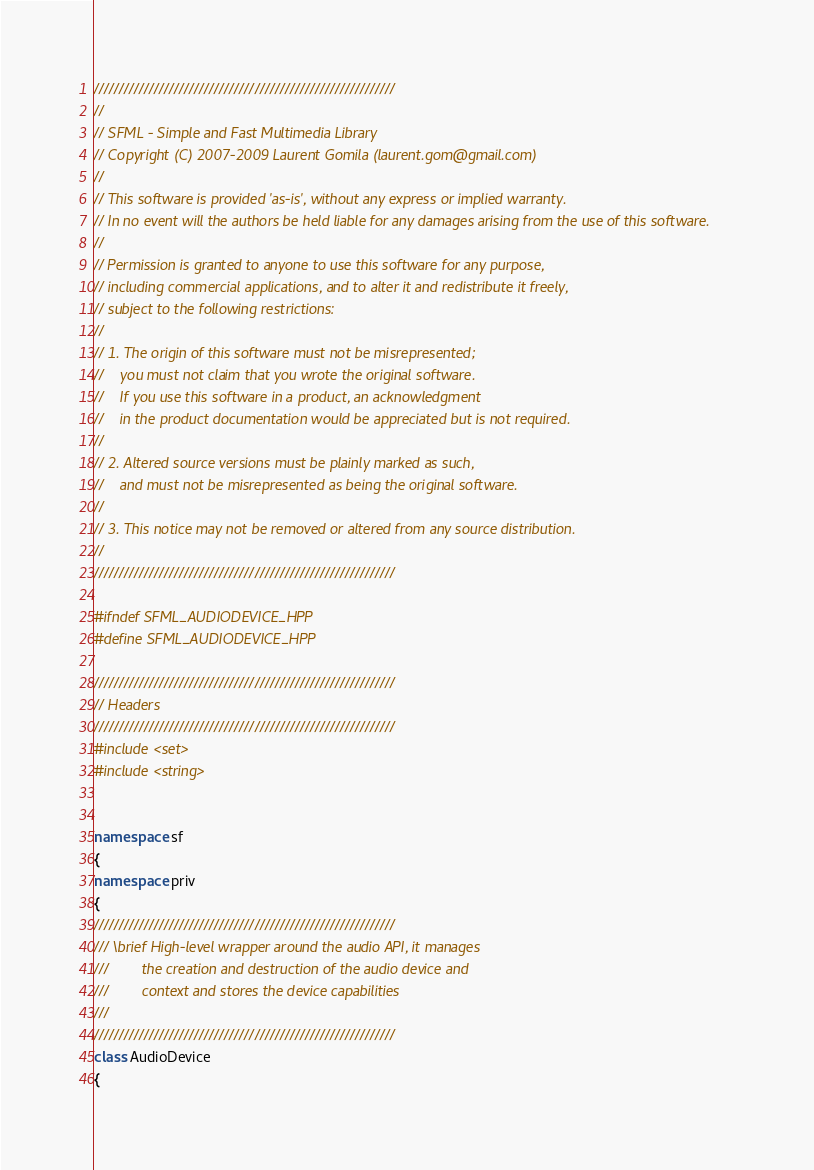Convert code to text. <code><loc_0><loc_0><loc_500><loc_500><_C++_>////////////////////////////////////////////////////////////
//
// SFML - Simple and Fast Multimedia Library
// Copyright (C) 2007-2009 Laurent Gomila (laurent.gom@gmail.com)
//
// This software is provided 'as-is', without any express or implied warranty.
// In no event will the authors be held liable for any damages arising from the use of this software.
//
// Permission is granted to anyone to use this software for any purpose,
// including commercial applications, and to alter it and redistribute it freely,
// subject to the following restrictions:
//
// 1. The origin of this software must not be misrepresented;
//    you must not claim that you wrote the original software.
//    If you use this software in a product, an acknowledgment
//    in the product documentation would be appreciated but is not required.
//
// 2. Altered source versions must be plainly marked as such,
//    and must not be misrepresented as being the original software.
//
// 3. This notice may not be removed or altered from any source distribution.
//
////////////////////////////////////////////////////////////

#ifndef SFML_AUDIODEVICE_HPP
#define SFML_AUDIODEVICE_HPP

////////////////////////////////////////////////////////////
// Headers
////////////////////////////////////////////////////////////
#include <set>
#include <string>


namespace sf
{
namespace priv
{
////////////////////////////////////////////////////////////
/// \brief High-level wrapper around the audio API, it manages
///        the creation and destruction of the audio device and
///        context and stores the device capabilities
///
////////////////////////////////////////////////////////////
class AudioDevice
{</code> 